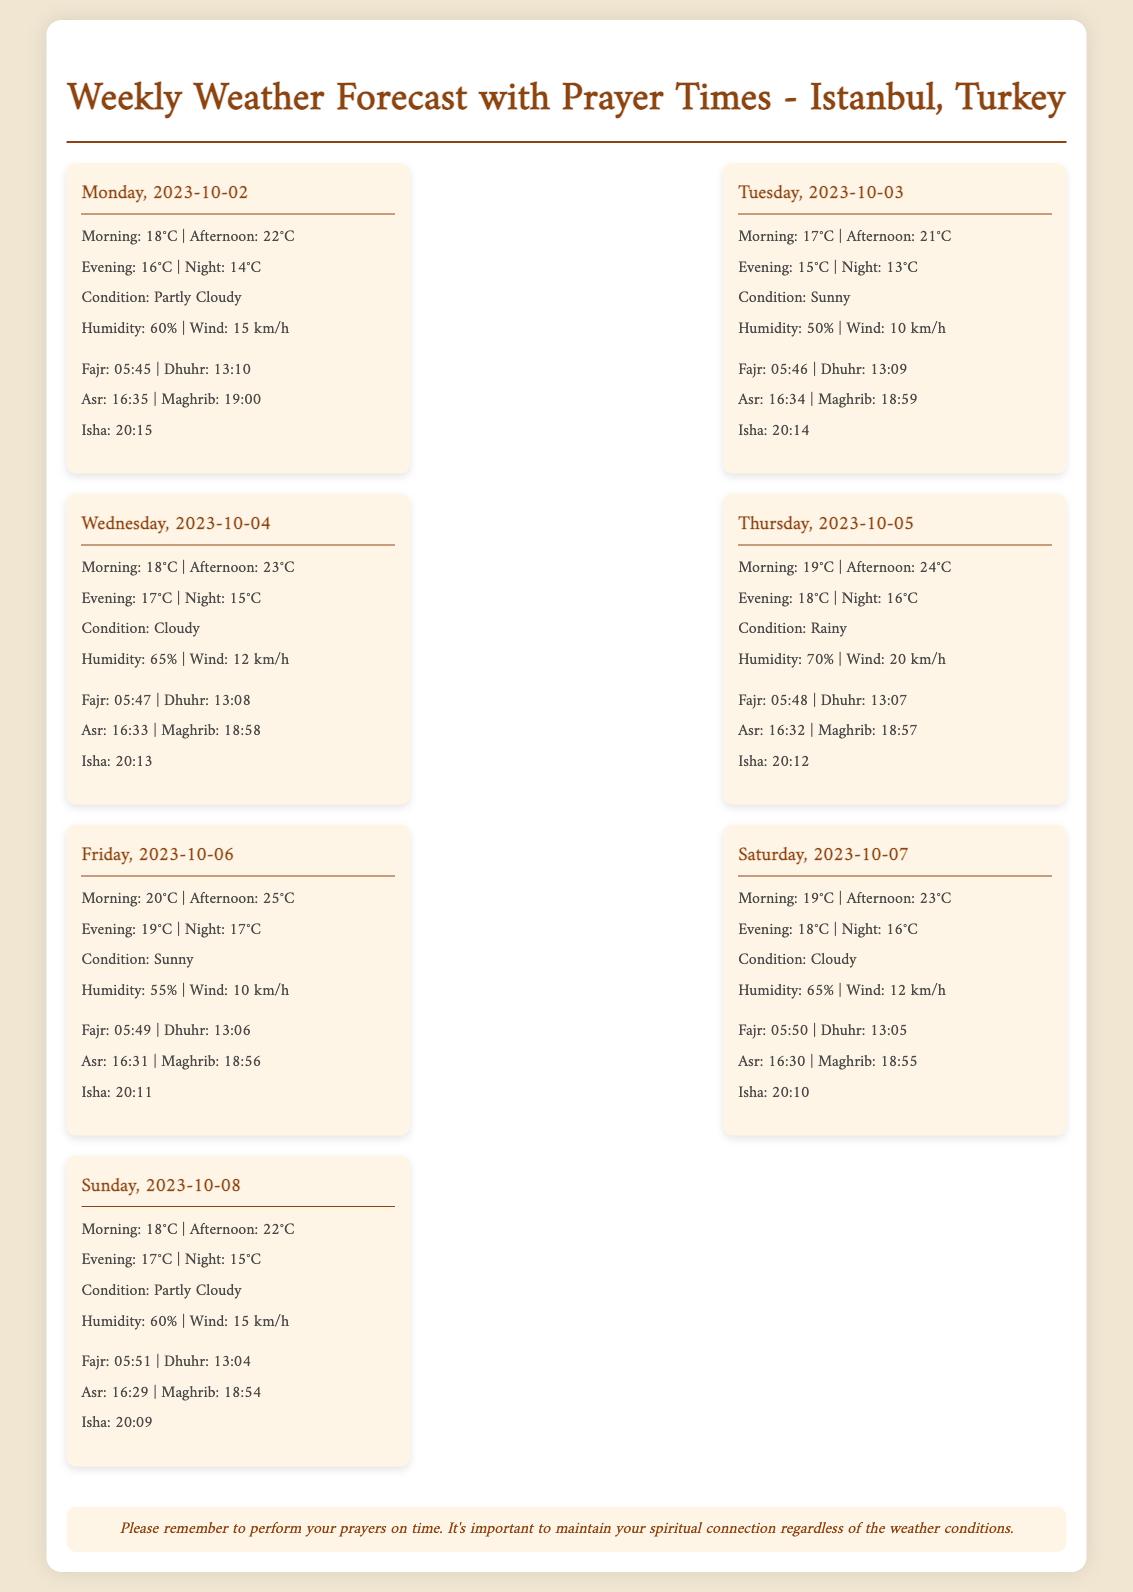what is the date for Friday? The date for Friday in the document is mentioned as October 6, 2023.
Answer: 2023-10-06 what is the condition for Thursday? The weather condition for Thursday is stated as Rainy.
Answer: Rainy what is the evening temperature on Wednesday? The evening temperature for Wednesday is listed as 17°C.
Answer: 17°C when is Isha prayer time for Sunday? The Isha prayer time for Sunday is provided in the document as 20:09.
Answer: 20:09 which day has the highest afternoon temperature? The highest afternoon temperature is noted for Friday, at 25°C.
Answer: Friday what is the humidity percentage on Tuesday? The humidity percentage on Tuesday is presented as 50%.
Answer: 50% how many days report a cloudy condition? The report indicates that there are two days with a cloudy condition (Wednesday and Saturday).
Answer: 2 what are the prayer times listed for Fajr on Monday? The Fajr prayer time for Monday is given as 05:45.
Answer: 05:45 what is the reminder message at the end of the document? The reminder message emphasizes the importance of performing prayers on time, regardless of weather conditions.
Answer: Please remember to perform your prayers on time 